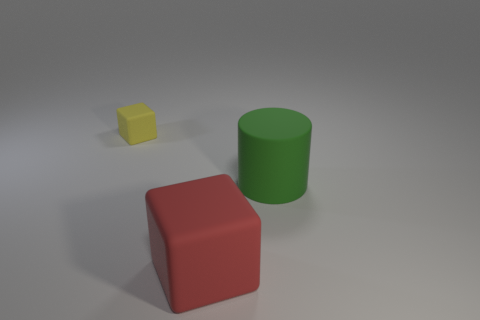Add 3 large cylinders. How many objects exist? 6 Subtract all cylinders. How many objects are left? 2 Add 2 cubes. How many cubes are left? 4 Add 2 yellow metallic cylinders. How many yellow metallic cylinders exist? 2 Subtract 1 green cylinders. How many objects are left? 2 Subtract all large green cylinders. Subtract all large cylinders. How many objects are left? 1 